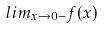Convert formula to latex. <formula><loc_0><loc_0><loc_500><loc_500>l i m _ { x \rightarrow 0 - } f ( x )</formula> 